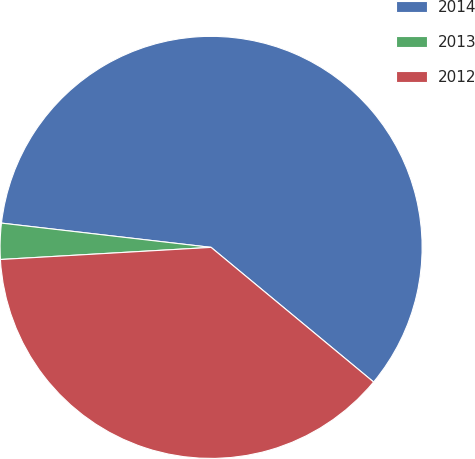Convert chart to OTSL. <chart><loc_0><loc_0><loc_500><loc_500><pie_chart><fcel>2014<fcel>2013<fcel>2012<nl><fcel>59.17%<fcel>2.75%<fcel>38.07%<nl></chart> 